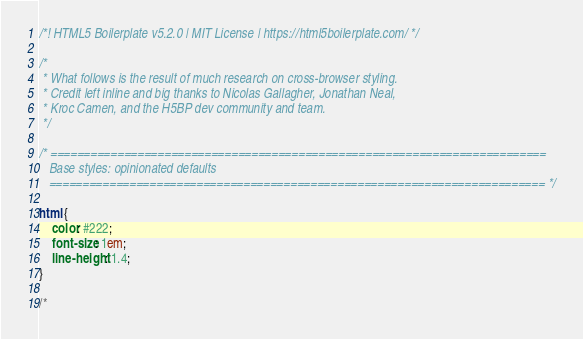<code> <loc_0><loc_0><loc_500><loc_500><_CSS_>/*! HTML5 Boilerplate v5.2.0 | MIT License | https://html5boilerplate.com/ */

/*
 * What follows is the result of much research on cross-browser styling.
 * Credit left inline and big thanks to Nicolas Gallagher, Jonathan Neal,
 * Kroc Camen, and the H5BP dev community and team.
 */

/* ==========================================================================
   Base styles: opinionated defaults
   ========================================================================== */

html {
    color: #222;
    font-size: 1em;
    line-height: 1.4;
}

/*</code> 